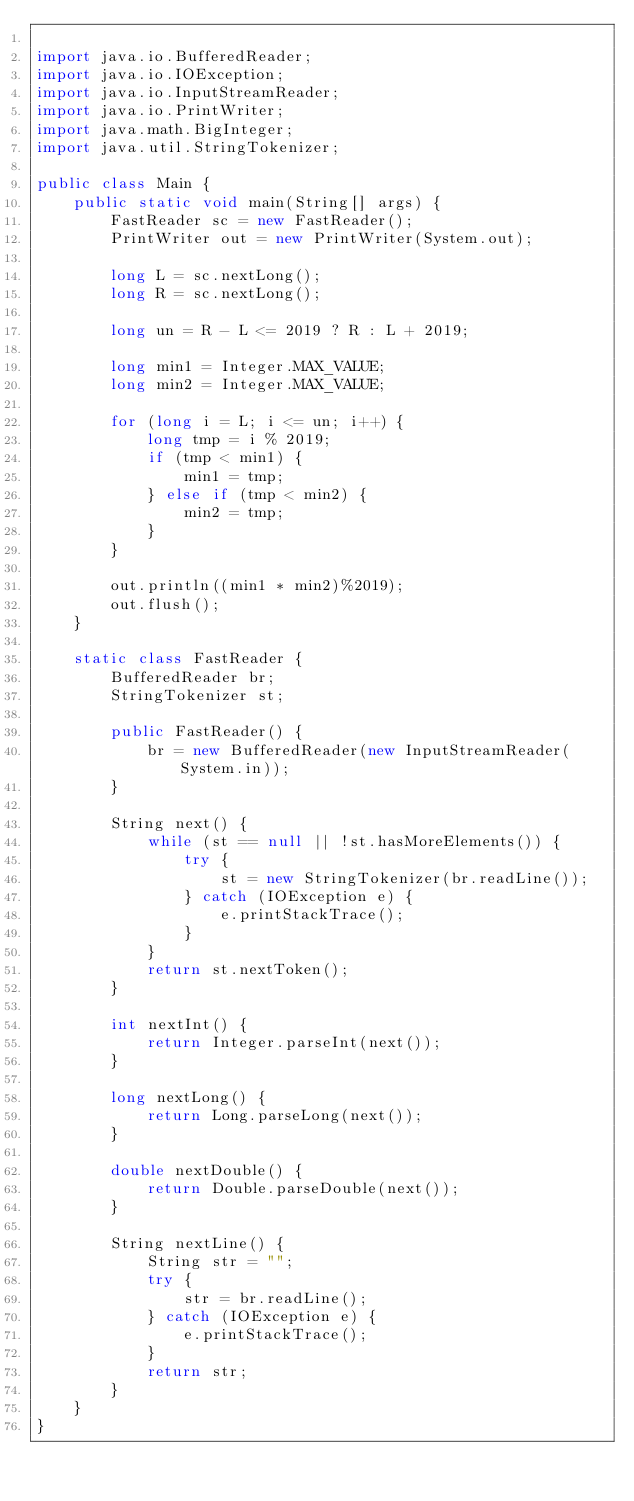<code> <loc_0><loc_0><loc_500><loc_500><_Java_>
import java.io.BufferedReader;
import java.io.IOException;
import java.io.InputStreamReader;
import java.io.PrintWriter;
import java.math.BigInteger;
import java.util.StringTokenizer;

public class Main {
    public static void main(String[] args) {
        FastReader sc = new FastReader();
        PrintWriter out = new PrintWriter(System.out);

        long L = sc.nextLong();
        long R = sc.nextLong();

        long un = R - L <= 2019 ? R : L + 2019;

        long min1 = Integer.MAX_VALUE;
        long min2 = Integer.MAX_VALUE;

        for (long i = L; i <= un; i++) {
            long tmp = i % 2019;
            if (tmp < min1) {
                min1 = tmp;
            } else if (tmp < min2) {
                min2 = tmp;
            }
        }

        out.println((min1 * min2)%2019);
        out.flush();
    }

    static class FastReader {
        BufferedReader br;
        StringTokenizer st;

        public FastReader() {
            br = new BufferedReader(new InputStreamReader(System.in));
        }

        String next() {
            while (st == null || !st.hasMoreElements()) {
                try {
                    st = new StringTokenizer(br.readLine());
                } catch (IOException e) {
                    e.printStackTrace();
                }
            }
            return st.nextToken();
        }

        int nextInt() {
            return Integer.parseInt(next());
        }

        long nextLong() {
            return Long.parseLong(next());
        }

        double nextDouble() {
            return Double.parseDouble(next());
        }

        String nextLine() {
            String str = "";
            try {
                str = br.readLine();
            } catch (IOException e) {
                e.printStackTrace();
            }
            return str;
        }
    }
}</code> 